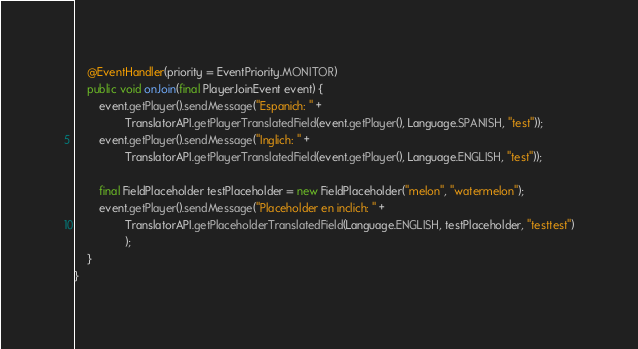<code> <loc_0><loc_0><loc_500><loc_500><_Java_>
    @EventHandler(priority = EventPriority.MONITOR)
    public void onJoin(final PlayerJoinEvent event) {
        event.getPlayer().sendMessage("Espanich: " +
                TranslatorAPI.getPlayerTranslatedField(event.getPlayer(), Language.SPANISH, "test"));
        event.getPlayer().sendMessage("Inglich: " +
                TranslatorAPI.getPlayerTranslatedField(event.getPlayer(), Language.ENGLISH, "test"));

        final FieldPlaceholder testPlaceholder = new FieldPlaceholder("melon", "watermelon");
        event.getPlayer().sendMessage("Placeholder en inclich: " +
                TranslatorAPI.getPlaceholderTranslatedField(Language.ENGLISH, testPlaceholder, "testtest")
                );
    }
}
</code> 